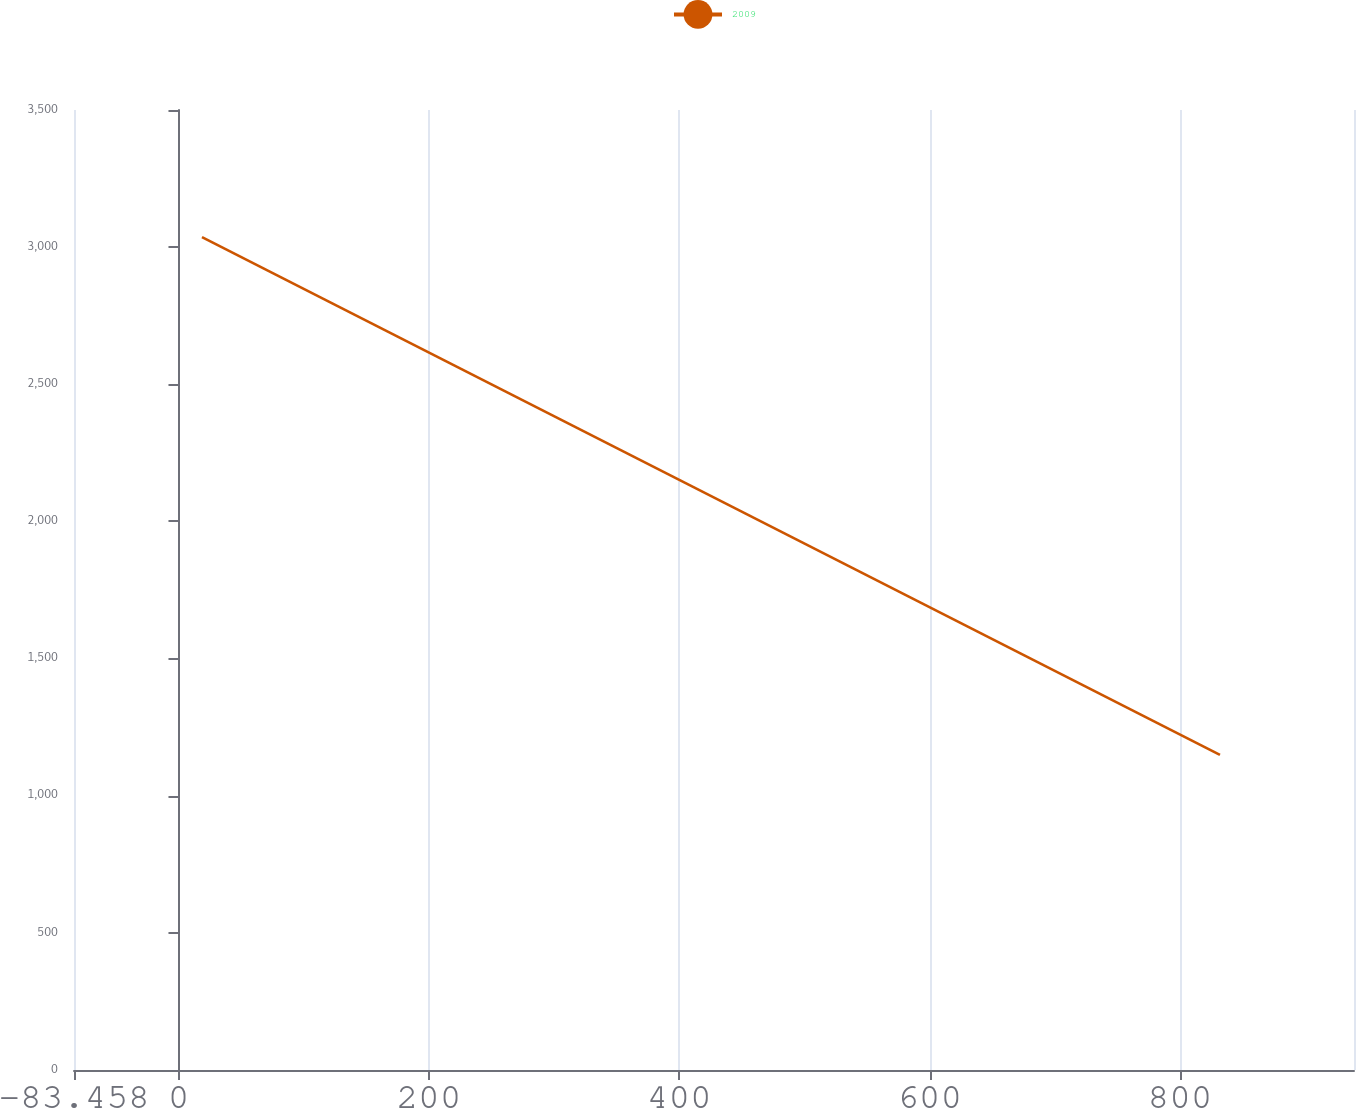Convert chart. <chart><loc_0><loc_0><loc_500><loc_500><line_chart><ecel><fcel>2009<nl><fcel>18.79<fcel>3036.77<nl><fcel>831.95<fcel>1149.17<nl><fcel>1041.27<fcel>3.17<nl></chart> 